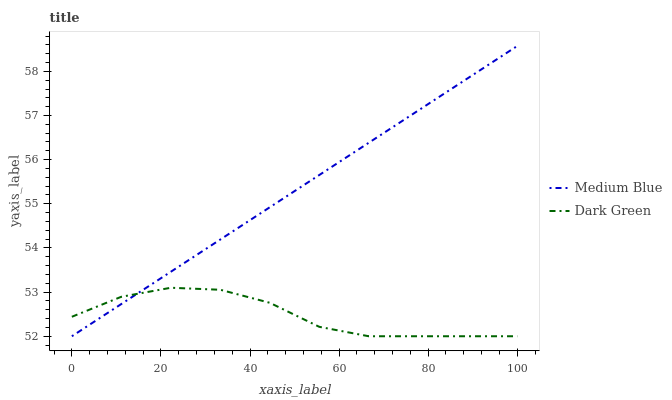Does Dark Green have the maximum area under the curve?
Answer yes or no. No. Is Dark Green the smoothest?
Answer yes or no. No. Does Dark Green have the highest value?
Answer yes or no. No. 